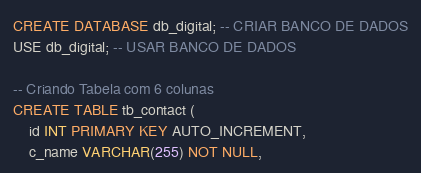<code> <loc_0><loc_0><loc_500><loc_500><_SQL_>CREATE DATABASE db_digital; -- CRIAR BANCO DE DADOS
USE db_digital; -- USAR BANCO DE DADOS

-- Criando Tabela com 6 colunas
CREATE TABLE tb_contact ( 
	id INT PRIMARY KEY AUTO_INCREMENT,
    c_name VARCHAR(255) NOT NULL,</code> 